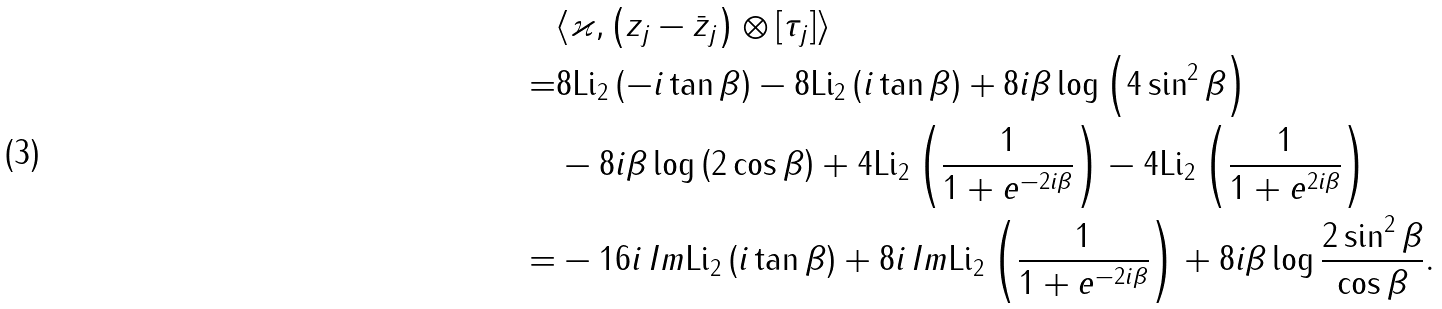<formula> <loc_0><loc_0><loc_500><loc_500>& \langle \varkappa , \left ( z _ { j } - \bar { z } _ { j } \right ) \otimes [ \tau _ { j } ] \rangle \\ = & 8 \text {Li} _ { 2 } \left ( - i \tan \beta \right ) - 8 \text {Li} _ { 2 } \left ( i \tan \beta \right ) + 8 i \beta \log \left ( 4 \sin ^ { 2 } \beta \right ) \\ & - 8 i \beta \log \left ( 2 \cos \beta \right ) + 4 \text {Li} _ { 2 } \left ( \frac { 1 } { 1 + e ^ { - 2 i \beta } } \right ) - 4 \text {Li} _ { 2 } \left ( \frac { 1 } { 1 + e ^ { 2 i \beta } } \right ) \\ = & - 1 6 i \, I m \text {Li} _ { 2 } \left ( i \tan \beta \right ) + 8 i \, I m \text {Li} _ { 2 } \left ( \frac { 1 } { 1 + e ^ { - 2 i \beta } } \right ) + 8 i \beta \log \frac { 2 \sin ^ { 2 } \beta } { \cos \beta } .</formula> 